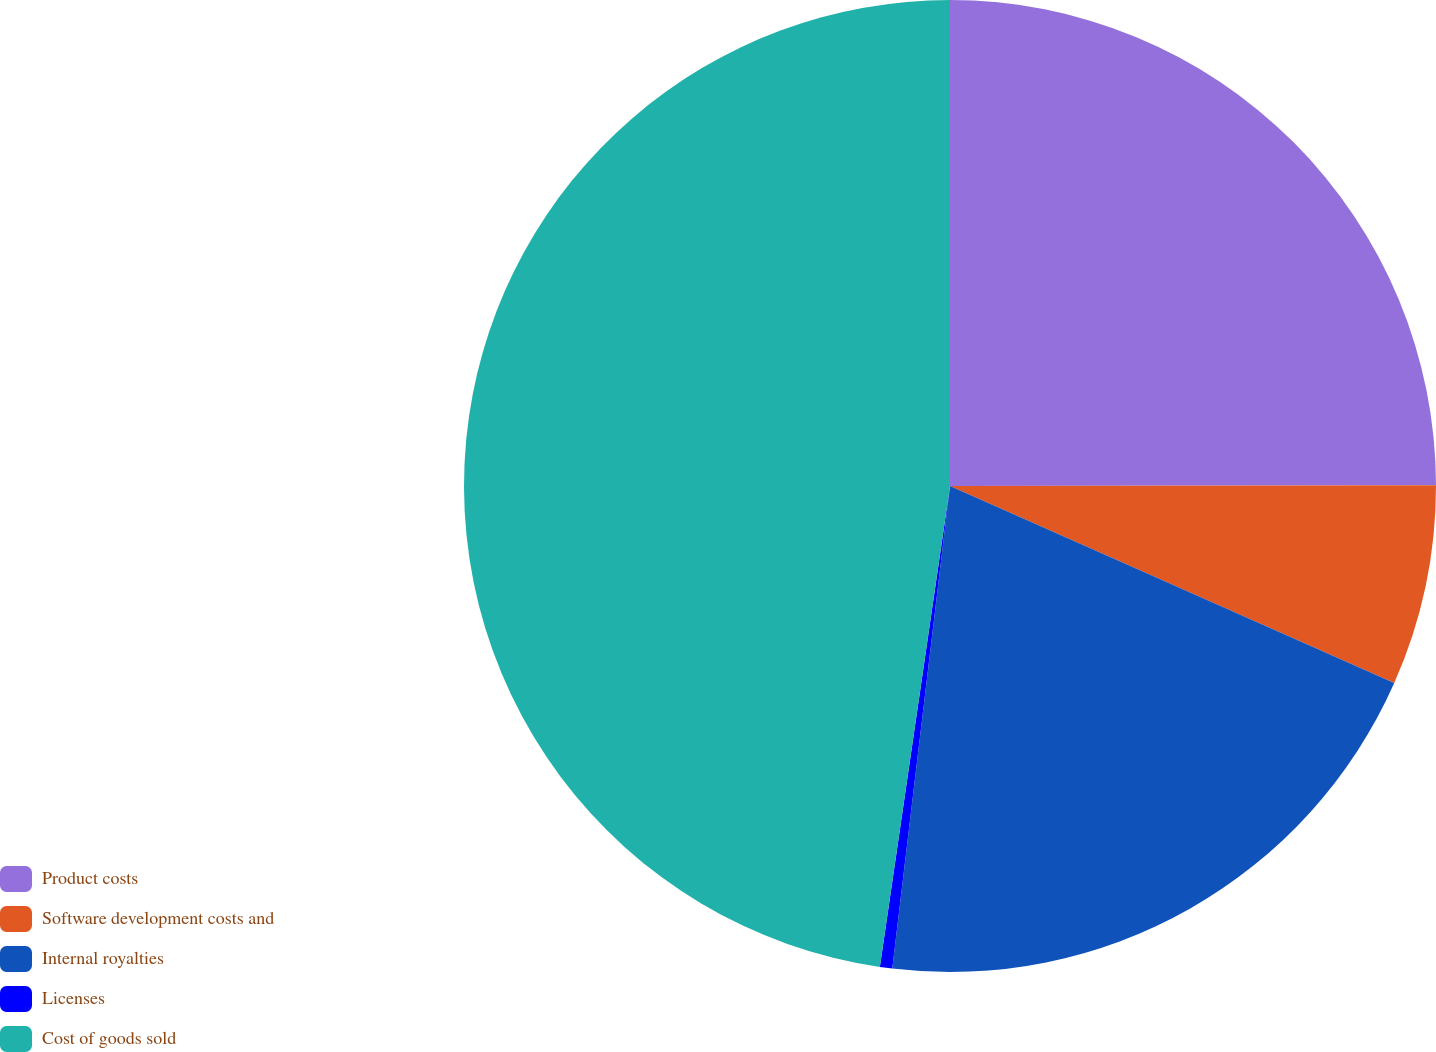Convert chart to OTSL. <chart><loc_0><loc_0><loc_500><loc_500><pie_chart><fcel>Product costs<fcel>Software development costs and<fcel>Internal royalties<fcel>Licenses<fcel>Cost of goods sold<nl><fcel>24.98%<fcel>6.67%<fcel>20.25%<fcel>0.41%<fcel>47.7%<nl></chart> 